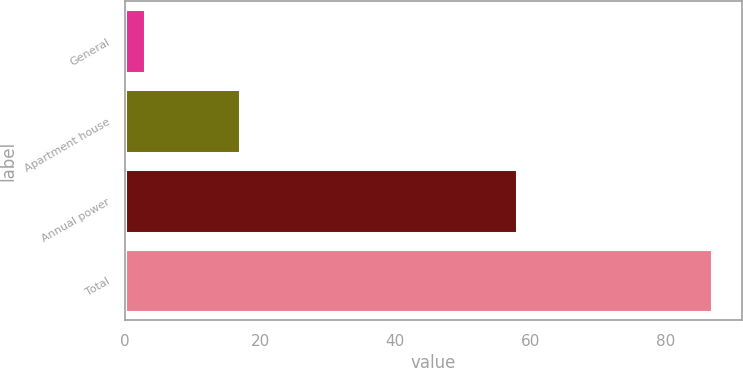Convert chart. <chart><loc_0><loc_0><loc_500><loc_500><bar_chart><fcel>General<fcel>Apartment house<fcel>Annual power<fcel>Total<nl><fcel>3<fcel>17<fcel>58<fcel>87<nl></chart> 